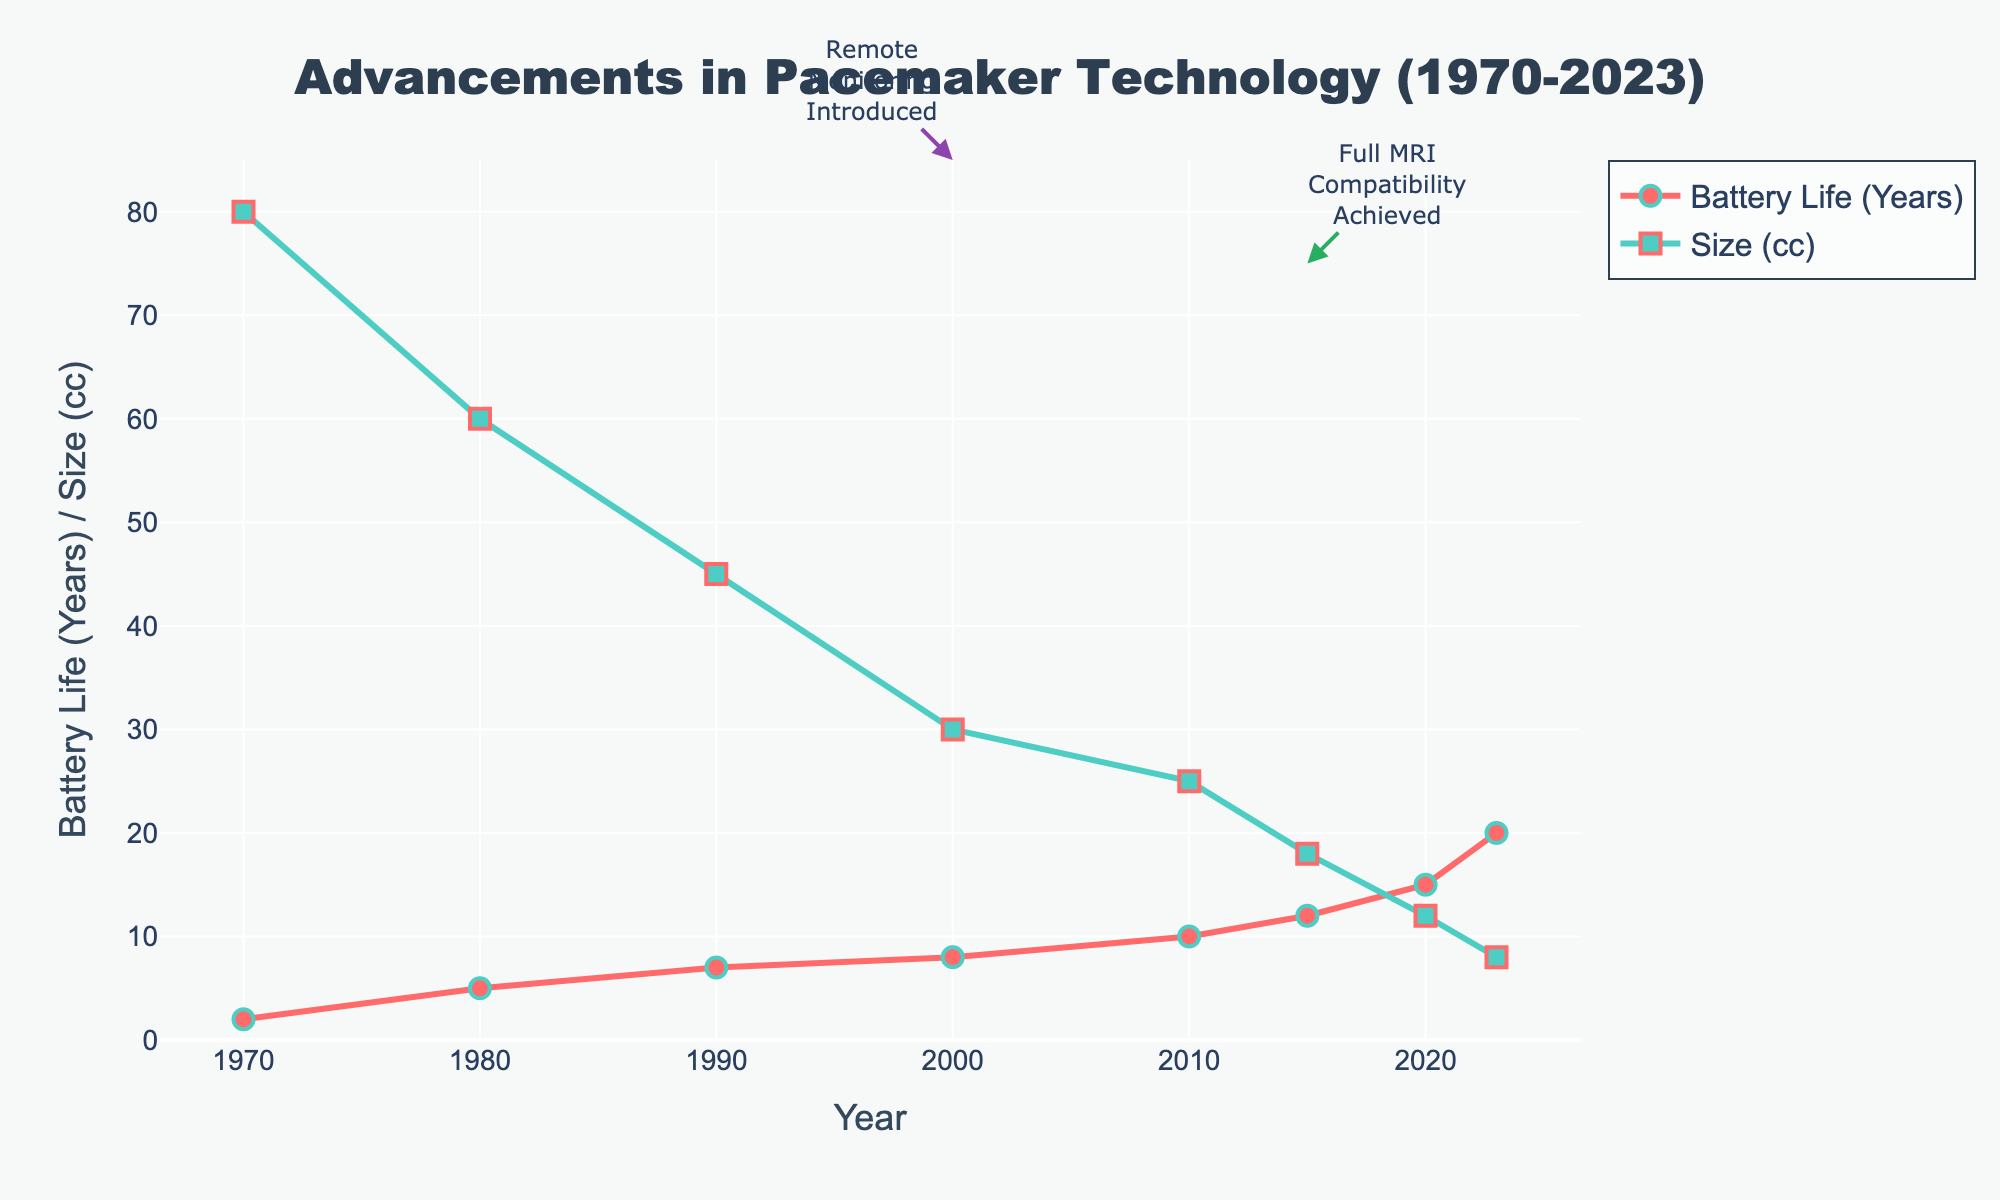What's the trend in battery life for pacemakers from 1970 to 2023? The trend in battery life can be observed by looking at the red line in the chart. From 1970 to 2023, the battery life of pacemakers has increased consistently each decade.
Answer: Increasing How much did the battery life improve from 1970 to 2023? The battery life increased from 2 years in 1970 to 20 years in 2023. The difference is calculated as 20 - 2.
Answer: 18 years Which year shows the first introduction of remote monitoring in pacemakers? The chart has an annotation marking the introduction of remote monitoring. The arrow points to the year when this feature was first introduced.
Answer: 2000 In which year did pacemakers achieve full MRI compatibility according to the chart? The chart has an annotation marking full MRI compatibility. The arrow pointing to the pertinent year is labeled with this achievement.
Answer: 2015 What is the trend in the size of pacemakers from 1970 to 2023? The trend in size can be observed by looking at the green line in the chart. From 1970 to 2023, the size of pacemakers has decreased steadily.
Answer: Decreasing Which year had a significant change in both remote monitoring and partial MRI compatibility features? Reviewing the annotations, the chart shows arrows pointing to the years where these features were introduced or changed. Both arrows related to remote monitoring and partial MRI compatibility coincide in this year.
Answer: 2010 Compare the battery life and size of pacemakers in 1980 and 1990. Which improved more remarkably? In 1980, the battery life was 5 years and the size was 60 cc. In 1990, the battery life increased to 7 years (a 2-year improvement) and the size reduced to 45 cc (a 15 cc reduction).
Answer: Size improved more remarkably What's the combined total improvement in battery life from 1970 to 2000, and from 2000 to 2023? From 1970 to 2000, the improvement in battery life was from 2 years to 8 years, which is 6 years. From 2000 to 2023, it improved from 8 years to 20 years, which is 12 years. The combined improvement is 6 + 12.
Answer: 18 years What is the size of pacemakers when they first achieved full MRI compatibility? According to the chart, full MRI compatibility was achieved in 2015. The green line shows the size in that year.
Answer: 18 cc 